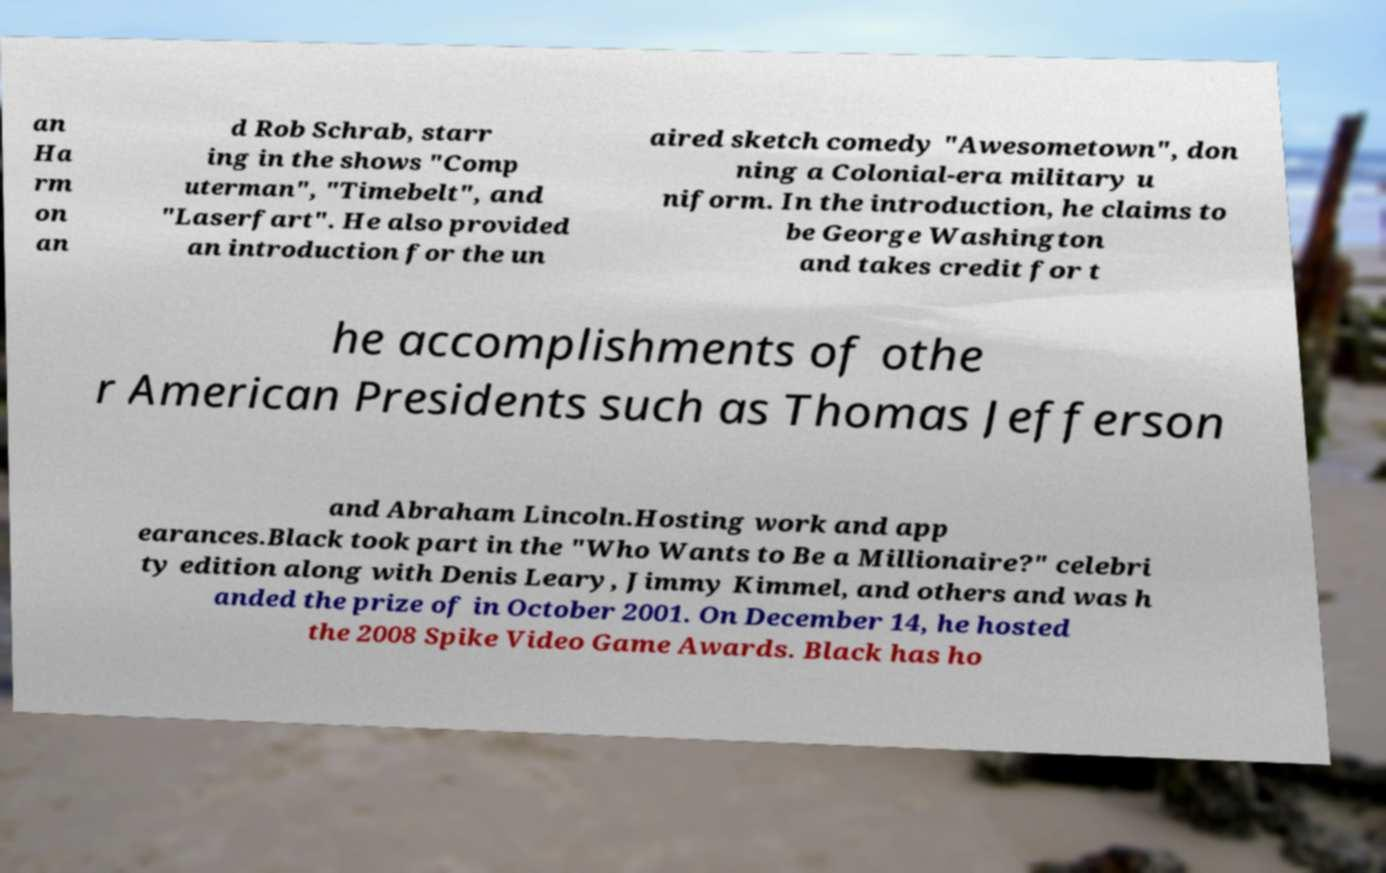For documentation purposes, I need the text within this image transcribed. Could you provide that? an Ha rm on an d Rob Schrab, starr ing in the shows "Comp uterman", "Timebelt", and "Laserfart". He also provided an introduction for the un aired sketch comedy "Awesometown", don ning a Colonial-era military u niform. In the introduction, he claims to be George Washington and takes credit for t he accomplishments of othe r American Presidents such as Thomas Jefferson and Abraham Lincoln.Hosting work and app earances.Black took part in the "Who Wants to Be a Millionaire?" celebri ty edition along with Denis Leary, Jimmy Kimmel, and others and was h anded the prize of in October 2001. On December 14, he hosted the 2008 Spike Video Game Awards. Black has ho 